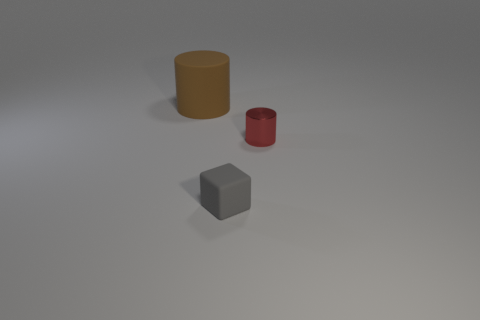How many red objects are small matte blocks or cylinders?
Your answer should be compact. 1. Is the number of matte cylinders that are to the left of the tiny gray object the same as the number of brown rubber things in front of the large rubber cylinder?
Your answer should be very brief. No. The rubber object left of the matte object that is in front of the cylinder that is on the left side of the gray block is what color?
Provide a succinct answer. Brown. Are there any other things that are the same color as the metallic cylinder?
Give a very brief answer. No. What size is the cylinder that is on the right side of the big matte cylinder?
Give a very brief answer. Small. There is a matte thing that is the same size as the metal cylinder; what shape is it?
Offer a very short reply. Cube. Are the cylinder that is behind the shiny thing and the cylinder that is right of the big brown object made of the same material?
Your answer should be very brief. No. What material is the cylinder that is right of the cylinder that is on the left side of the small red object made of?
Offer a terse response. Metal. How big is the matte thing that is on the right side of the big thing left of the small object behind the gray matte block?
Your answer should be very brief. Small. Do the red thing and the brown cylinder have the same size?
Offer a very short reply. No. 